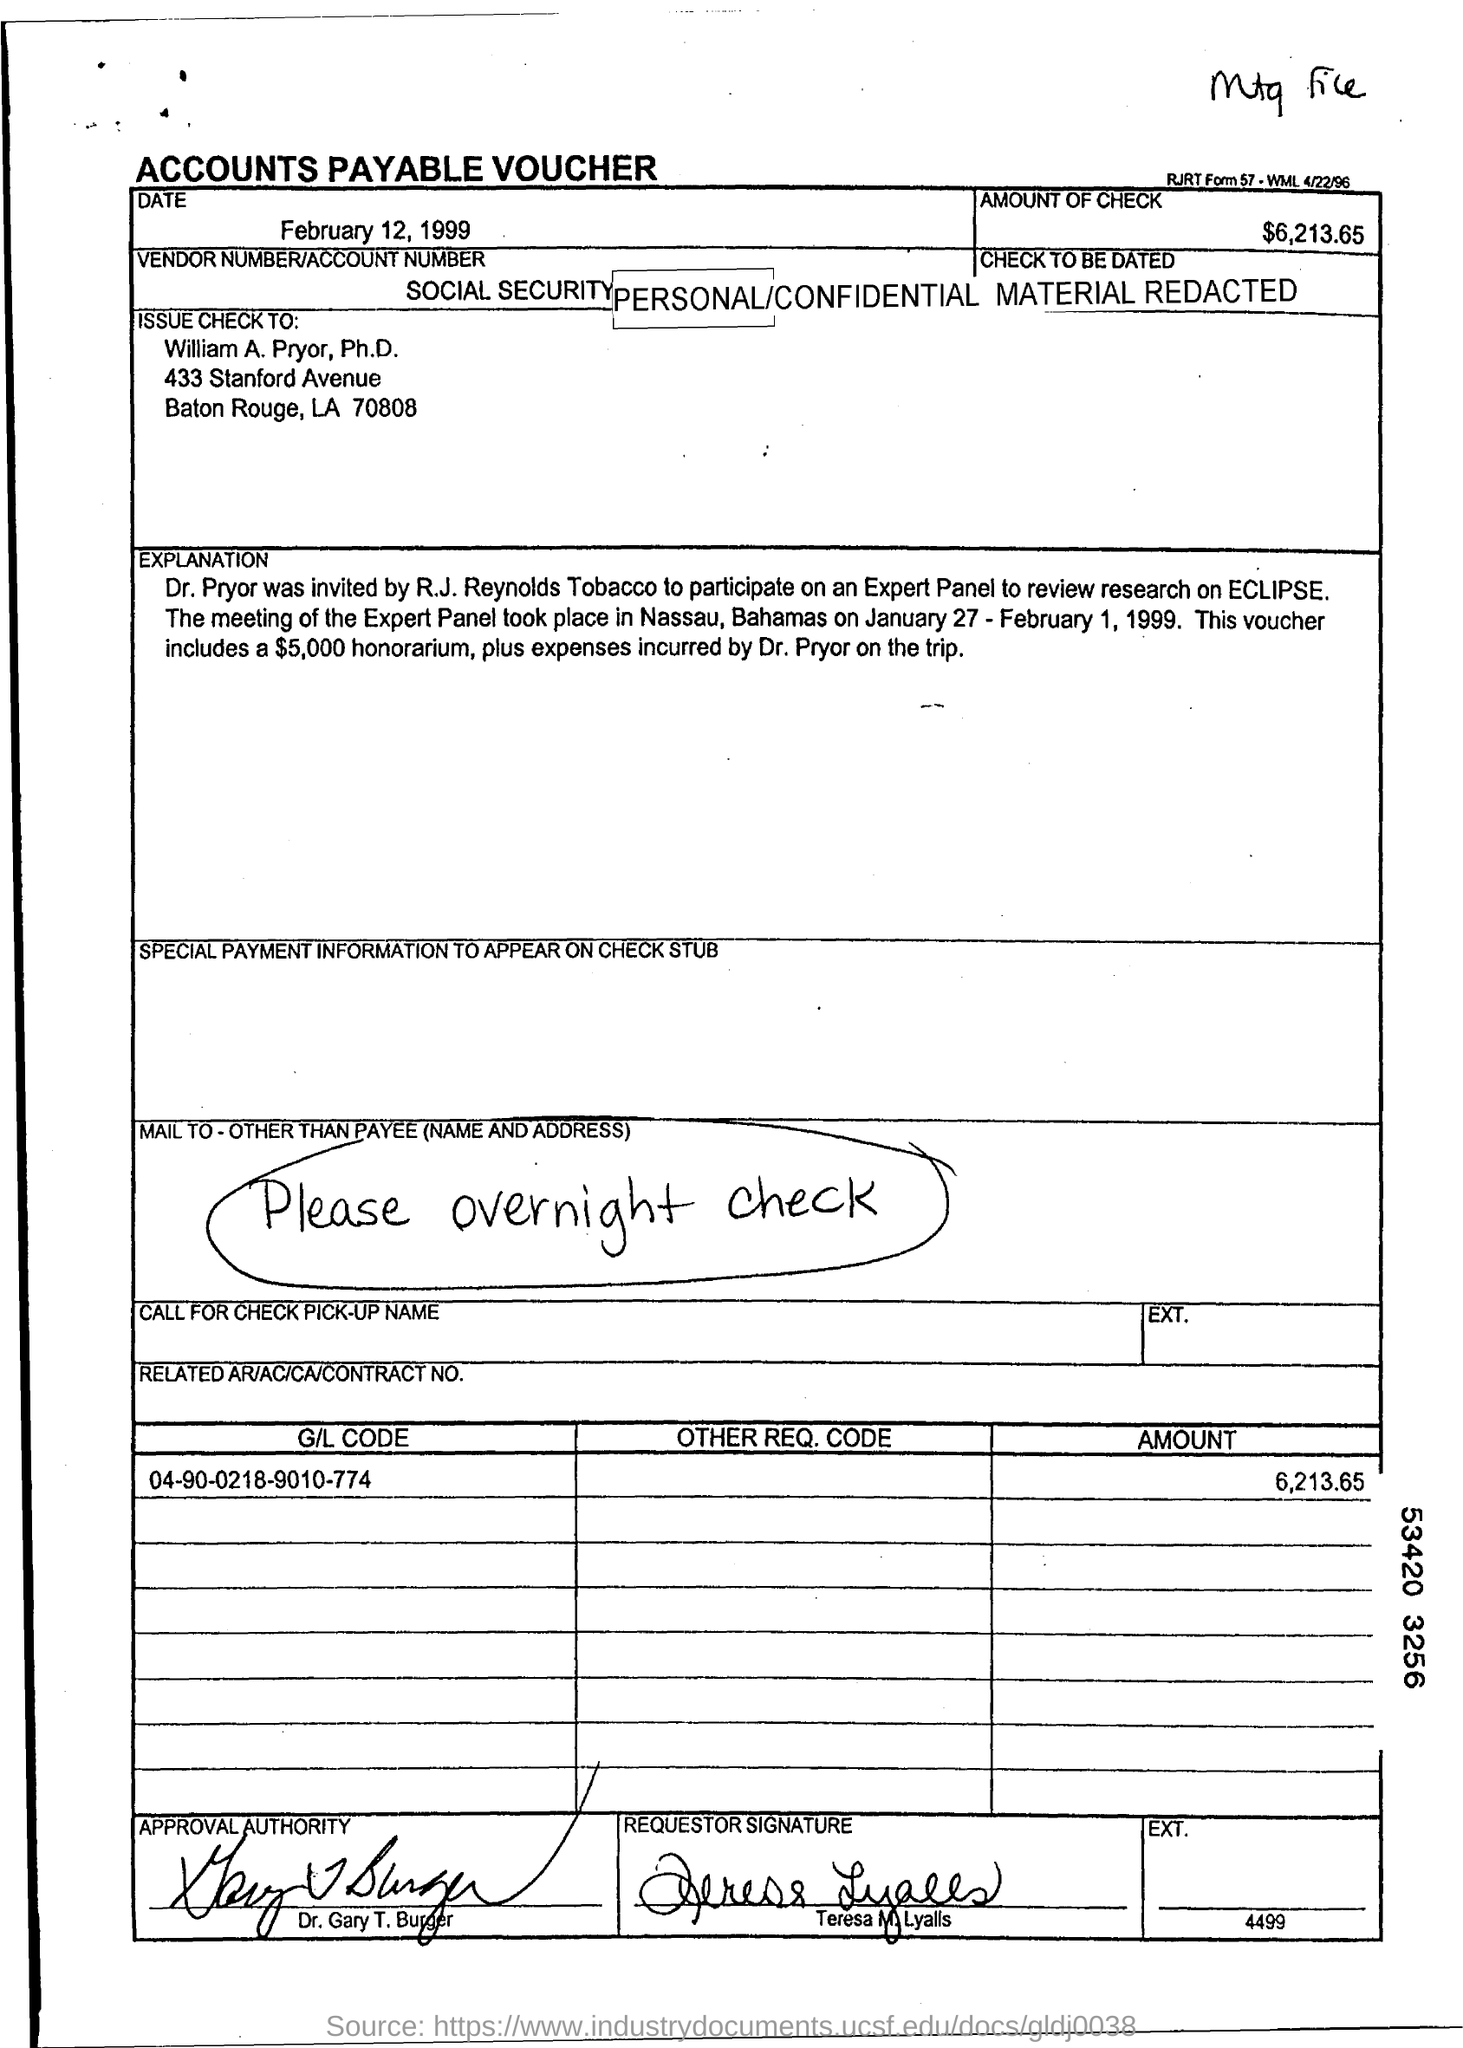What is the Date?
Your answer should be very brief. February 12, 1999. What is the Amount of Check?
Offer a very short reply. 6,213.65. Who is the Check issued to?
Offer a terse response. William A. Pryor, Ph.D. What is the G/L Code?
Your answer should be compact. 04-90-0218-9010-774. Who is the Approval Authority?
Provide a succinct answer. Dr. Gary T. Burger. Who is the Requestor?
Make the answer very short. Teresa M. Lyalls. 